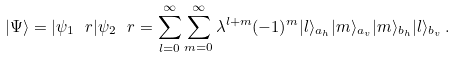<formula> <loc_0><loc_0><loc_500><loc_500>| \Psi \rangle = | \psi _ { 1 } \ r | \psi _ { 2 } \ r = \sum _ { l = 0 } ^ { \infty } \sum _ { m = 0 } ^ { \infty } \lambda ^ { l + m } ( - 1 ) ^ { m } | l \rangle _ { a _ { h } } | m \rangle _ { a _ { v } } | m \rangle _ { b _ { h } } | l \rangle _ { b _ { v } } \, .</formula> 